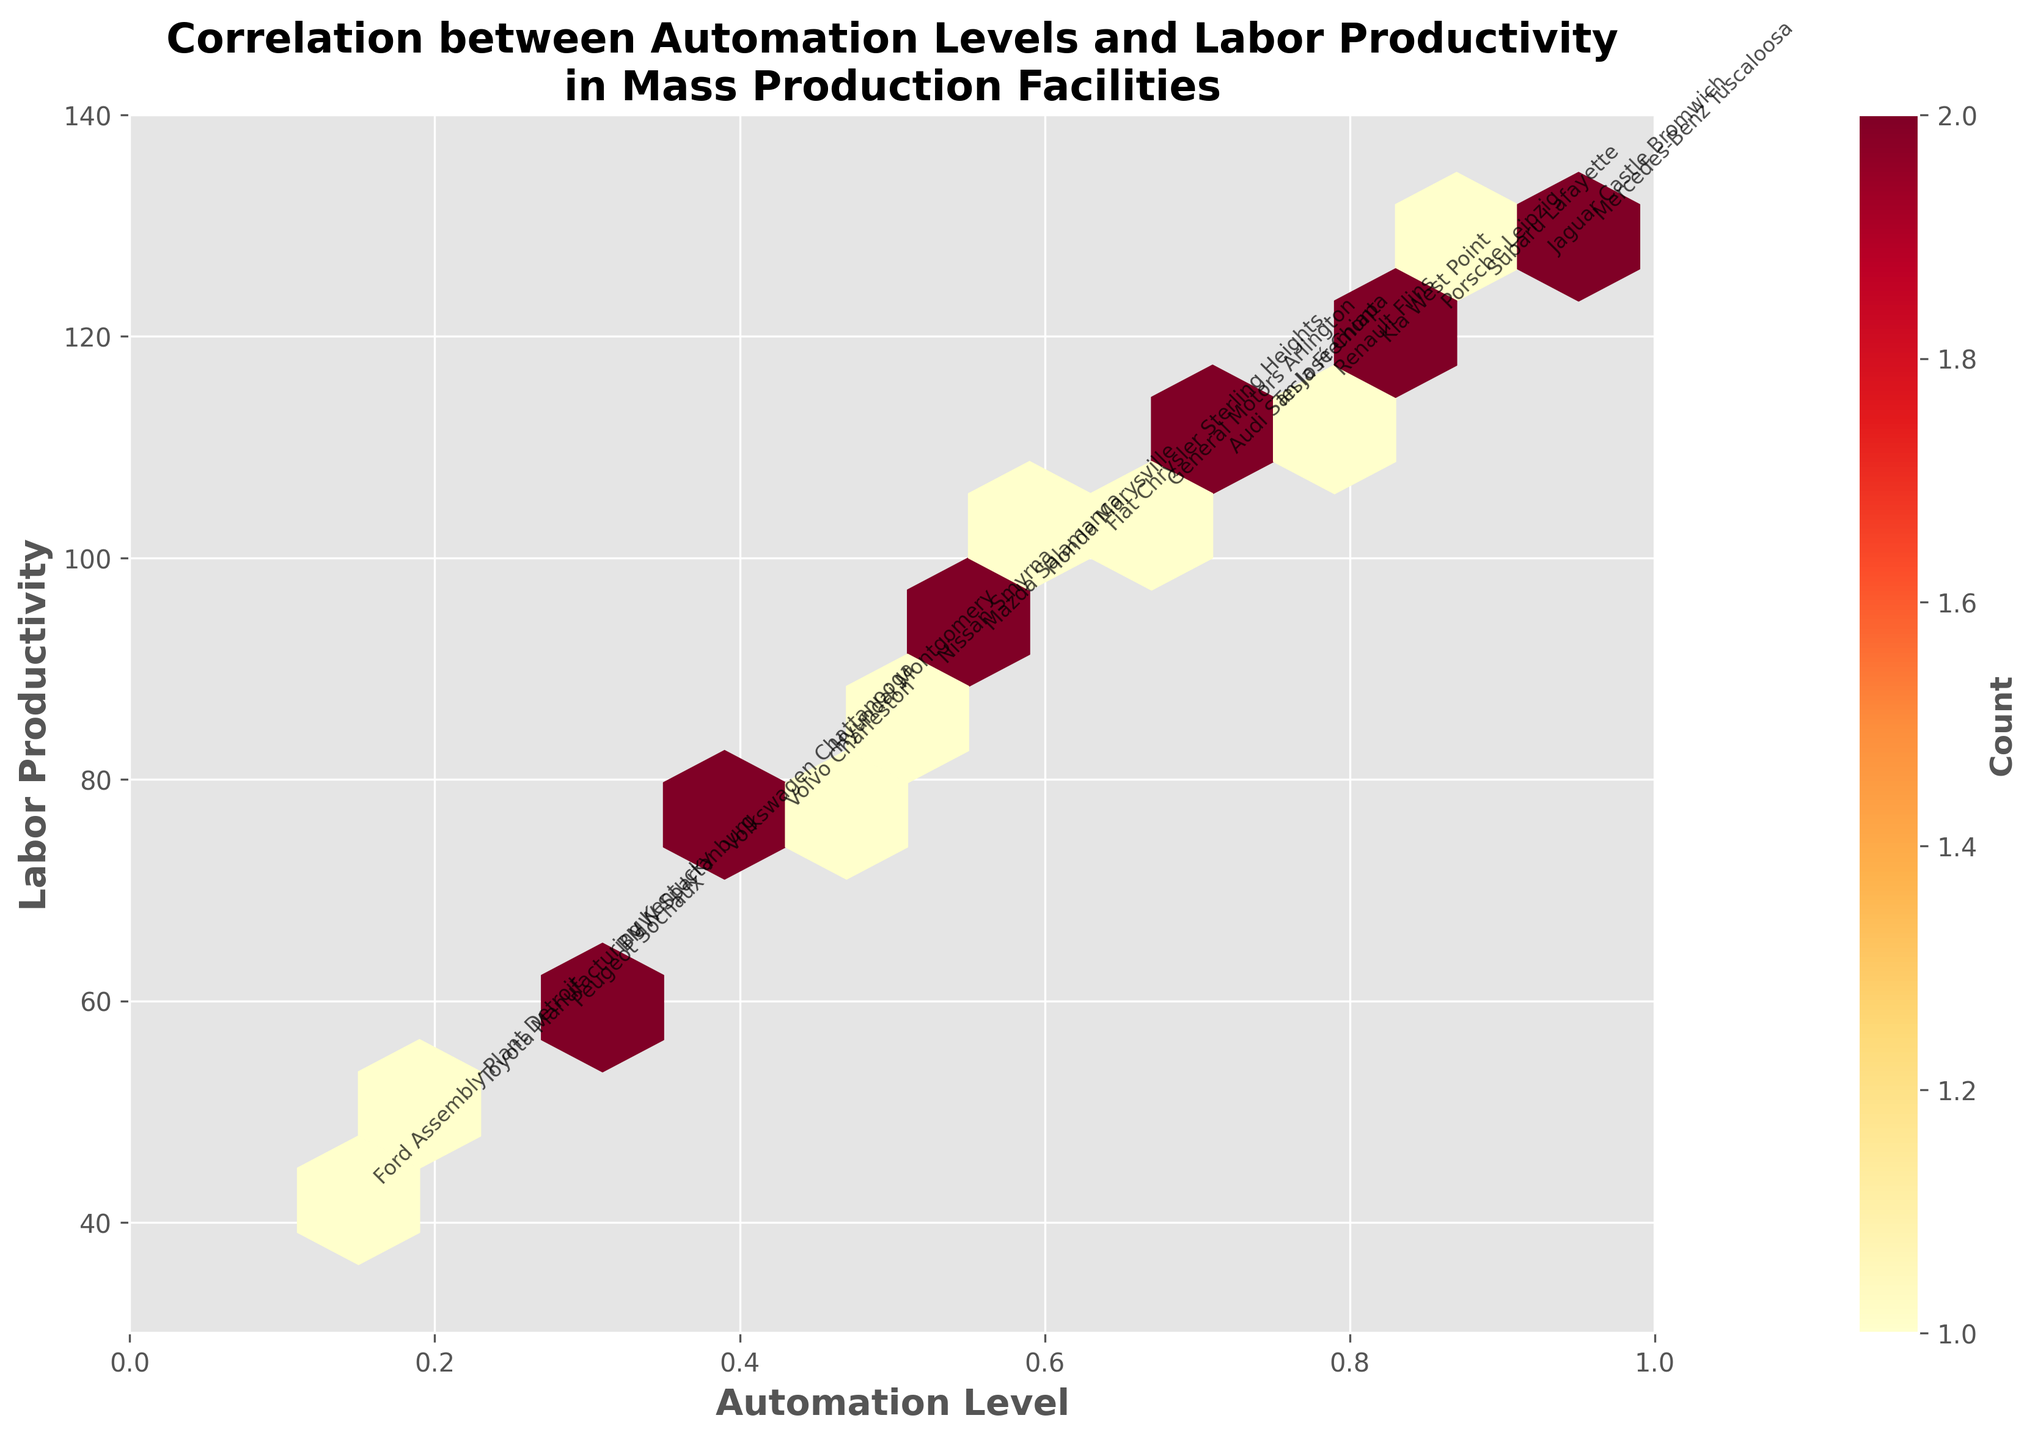what is the title of the plot? The title of the plot is displayed at the top and reads "Correlation between Automation Levels and Labor Productivity in Mass Production Facilities." This information can be directly gathered from the visual inspection of the title.
Answer: Correlation between Automation Levels and Labor Productivity in Mass Production Facilities What does the color intensity represent? The color intensity, represented by the colormap ranging from yellow to red, indicates the count of data points. Higher intensity (more towards red) means a higher count of data points in that particular bin. This is a visual characteristic specific to hexbin plots.
Answer: Count of data points Which facility has the highest labor productivity? The facility with the highest labor productivity can be identified by looking at the highest point on the Y-axis (Labor Productivity). The point with the highest Y-value corresponds to the facility name annotated at that position.
Answer: Mercedes-Benz Tuscaloosa Approximately how many data points fall between an automation level of 0.5 and 0.7? To determine this, look at the hexagonal bins covering the range between 0.5 and 0.7 on the x-axis. The color density and the color bar can help estimate the number of data points in this range by summing up the counts indicated by the color intensities.
Answer: Around 4-6 What is the relationship between automation level and labor productivity? Observing the general trend of the plotted data points, there appears to be a positive correlation: as the automation level increases, labor productivity also tends to increase. This can be inferred from the upward slope formed by the concentration of data points.
Answer: Positive correlation Which facility has an automation level closest to 0.7? By locating the point closest to 0.7 on the x-axis and checking the annotated facility name at that position, we can identify the facility. The point at approximately this x-value corresponds to the text label "Audi San José Chiapa."
Answer: Audi San José Chiapa What range does the color bar represent? The color bar on the side of the hexbin plot indicates the range of counts within each hexagon, specifically from a minimum of 1 to around the higher counts of data points. This information is derived from the color bar labels.
Answer: 1 to highest count How many facilities have been plotted in this figure? Each facility is represented by an annotated name, and counting these names provides the total number of facilities plotted.
Answer: 20 Which facility, with a productivity level above 100, has the lowest automation level? Facility names and their positions can determine this. Identifying points above the 100-mark on the y-axis and checking their corresponding x-values, Subaru Lafayette is closest to the lowest automation level among them.
Answer: Subaru Lafayette 